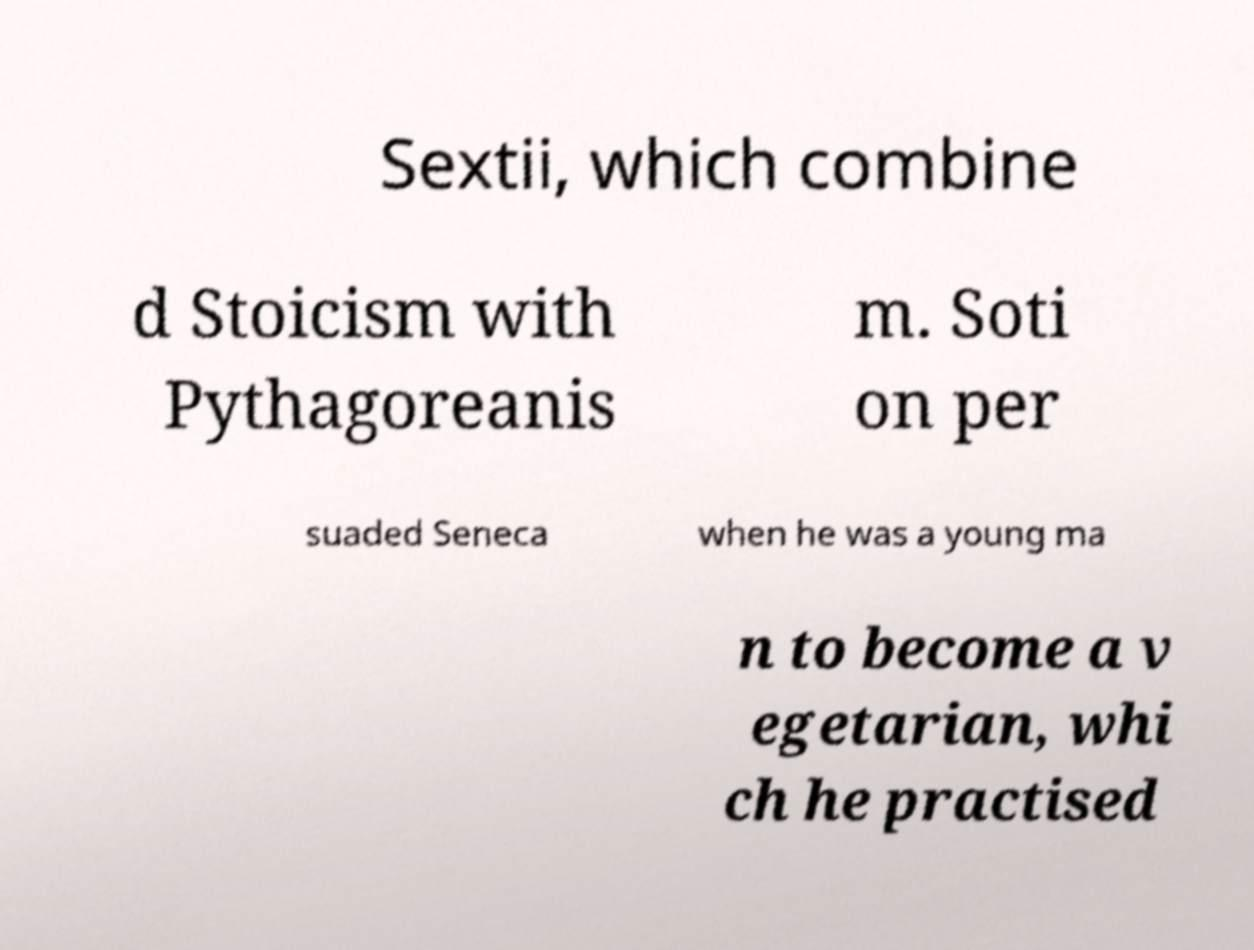There's text embedded in this image that I need extracted. Can you transcribe it verbatim? Sextii, which combine d Stoicism with Pythagoreanis m. Soti on per suaded Seneca when he was a young ma n to become a v egetarian, whi ch he practised 